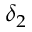<formula> <loc_0><loc_0><loc_500><loc_500>\delta _ { 2 }</formula> 